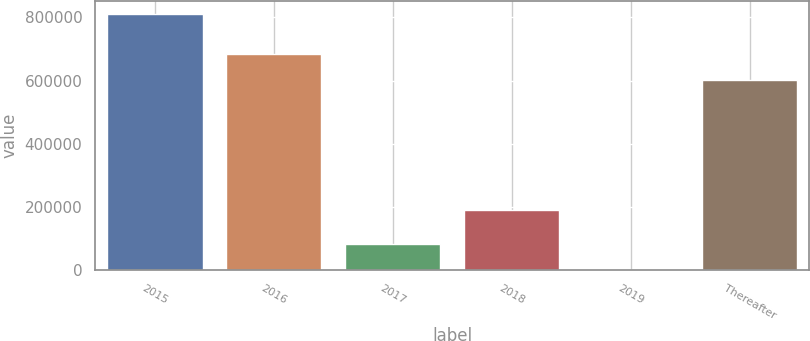<chart> <loc_0><loc_0><loc_500><loc_500><bar_chart><fcel>2015<fcel>2016<fcel>2017<fcel>2018<fcel>2019<fcel>Thereafter<nl><fcel>810477<fcel>683612<fcel>81755.1<fcel>191792<fcel>786<fcel>602643<nl></chart> 